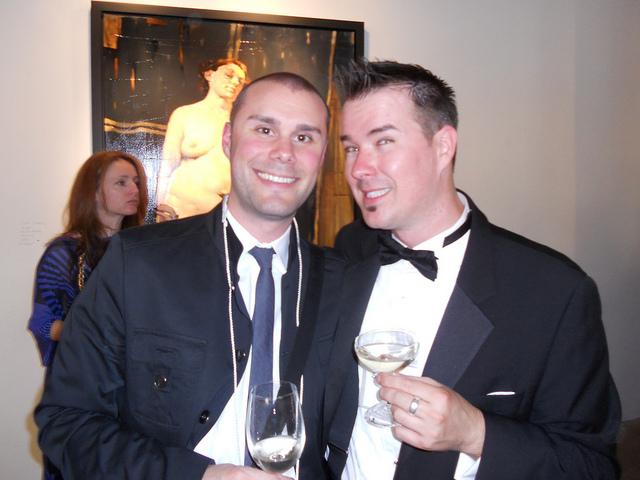From what fruit comes the item being drunk here? Please explain your reasoning. grapes. The fruit is grapes. 